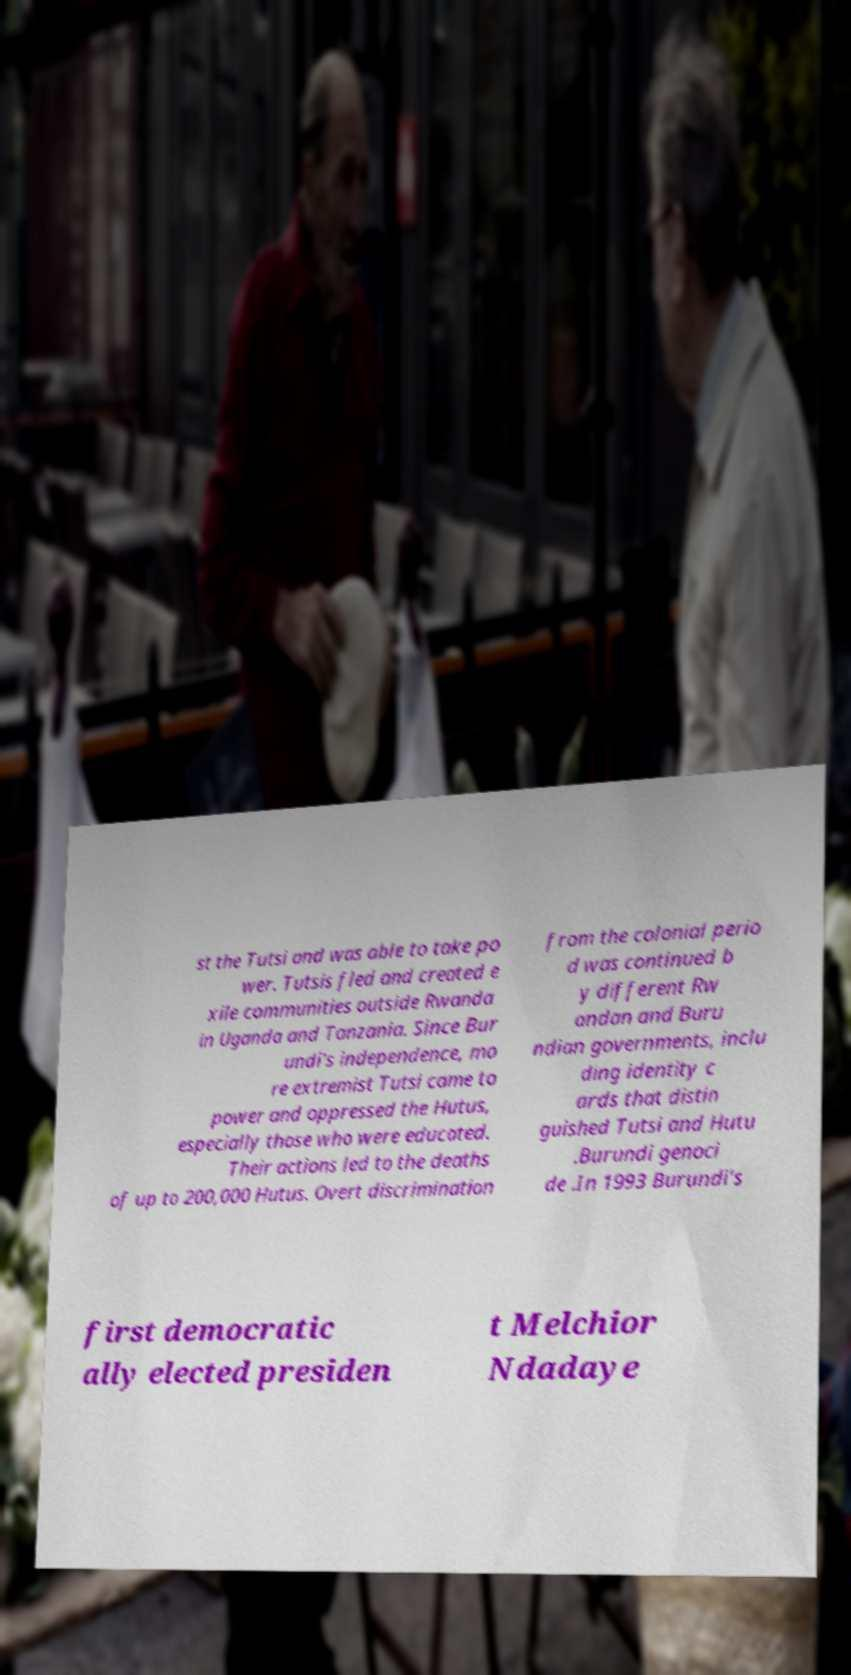Please read and relay the text visible in this image. What does it say? st the Tutsi and was able to take po wer. Tutsis fled and created e xile communities outside Rwanda in Uganda and Tanzania. Since Bur undi's independence, mo re extremist Tutsi came to power and oppressed the Hutus, especially those who were educated. Their actions led to the deaths of up to 200,000 Hutus. Overt discrimination from the colonial perio d was continued b y different Rw andan and Buru ndian governments, inclu ding identity c ards that distin guished Tutsi and Hutu .Burundi genoci de .In 1993 Burundi's first democratic ally elected presiden t Melchior Ndadaye 